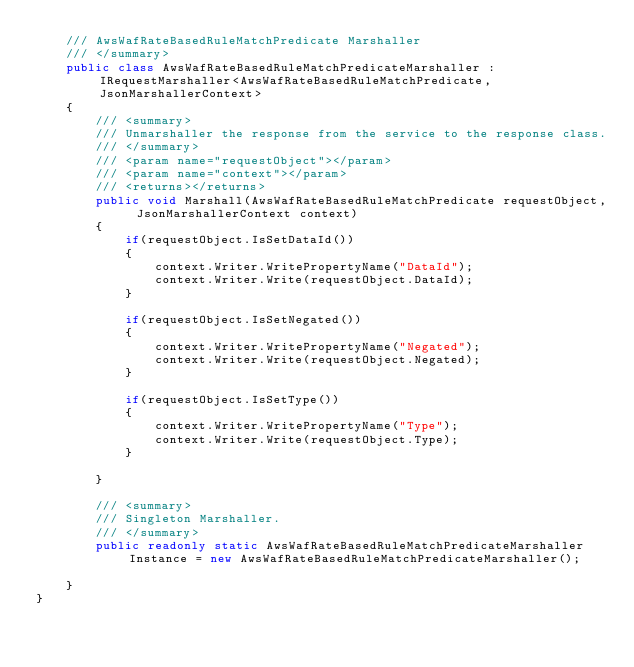<code> <loc_0><loc_0><loc_500><loc_500><_C#_>    /// AwsWafRateBasedRuleMatchPredicate Marshaller
    /// </summary>       
    public class AwsWafRateBasedRuleMatchPredicateMarshaller : IRequestMarshaller<AwsWafRateBasedRuleMatchPredicate, JsonMarshallerContext> 
    {
        /// <summary>
        /// Unmarshaller the response from the service to the response class.
        /// </summary>  
        /// <param name="requestObject"></param>
        /// <param name="context"></param>
        /// <returns></returns>
        public void Marshall(AwsWafRateBasedRuleMatchPredicate requestObject, JsonMarshallerContext context)
        {
            if(requestObject.IsSetDataId())
            {
                context.Writer.WritePropertyName("DataId");
                context.Writer.Write(requestObject.DataId);
            }

            if(requestObject.IsSetNegated())
            {
                context.Writer.WritePropertyName("Negated");
                context.Writer.Write(requestObject.Negated);
            }

            if(requestObject.IsSetType())
            {
                context.Writer.WritePropertyName("Type");
                context.Writer.Write(requestObject.Type);
            }

        }

        /// <summary>
        /// Singleton Marshaller.
        /// </summary>  
        public readonly static AwsWafRateBasedRuleMatchPredicateMarshaller Instance = new AwsWafRateBasedRuleMatchPredicateMarshaller();

    }
}</code> 